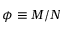<formula> <loc_0><loc_0><loc_500><loc_500>\phi \equiv M / N</formula> 